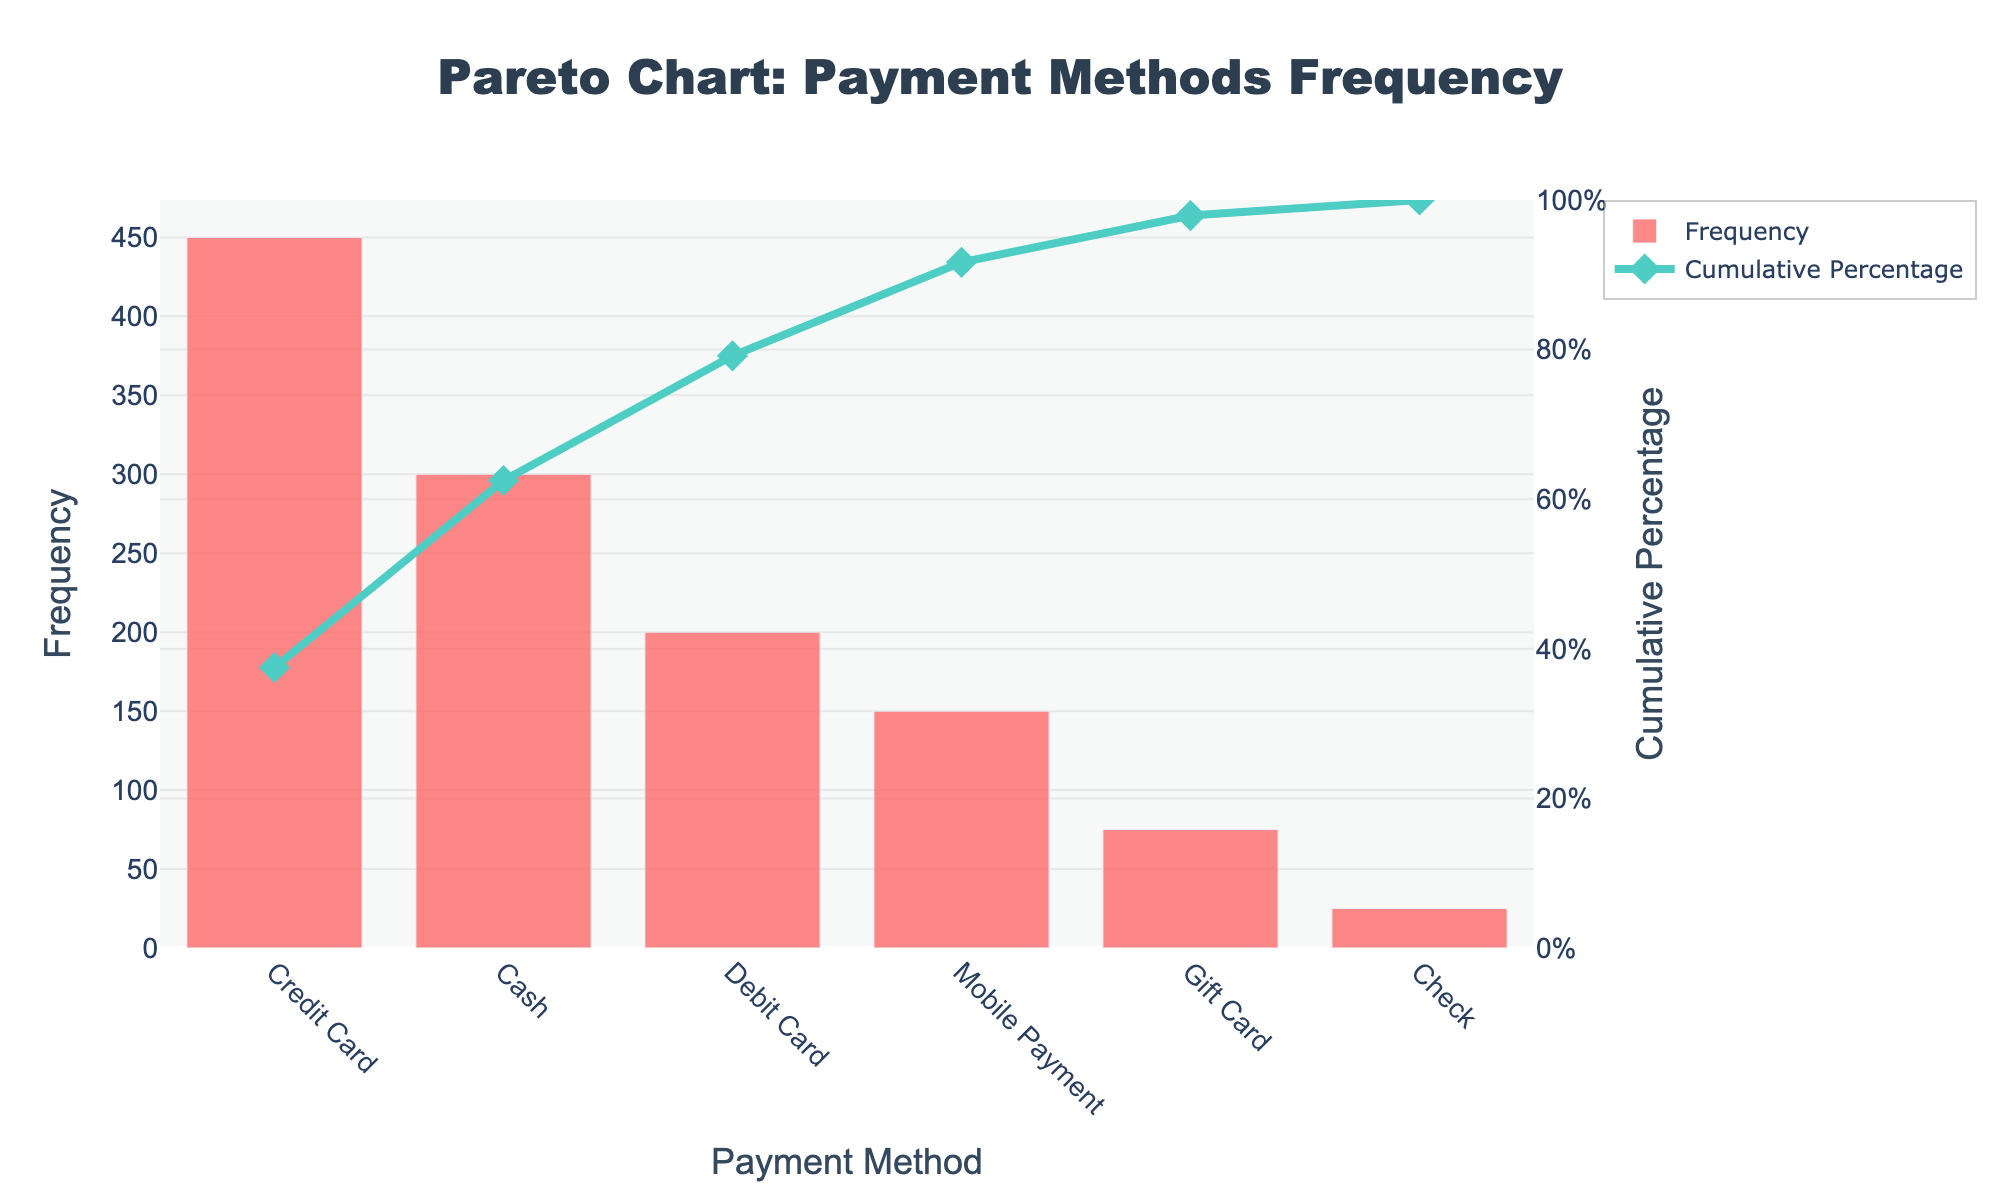What's the title of the Pareto chart? The title of the chart is located at the top and reads: "Pareto Chart: Payment Methods Frequency"
Answer: Pareto Chart: Payment Methods Frequency Which payment method has the highest frequency? From the bar chart, the payment method with the highest bar is "Credit Card" with a frequency of 450.
Answer: Credit Card What is the cumulative percentage for Debit Card? The cumulative percentage for "Debit Card" is shown on the line chart. It is approximately 81%.
Answer: 81% What two payment methods make up 75% of the cumulative percentage? To determine this, observe the cumulative percentage line chart. "Credit Card" (450) and "Cash" (300) together have a cumulative percentage of around 75%.
Answer: Credit Card and Cash How many payment methods are displayed on the x-axis? By counting the categories on the x-axis, we see there are 6 payment methods displayed: Credit Card, Cash, Debit Card, Mobile Payment, Gift Card, and Check.
Answer: 6 How does the frequency of Cash compare with Debit Card? From the bar chart, Cash has a higher frequency (300) compared to Debit Card (200).
Answer: Cash has a higher frequency than Debit Card What's the total cumulative percentage after including Mobile Payment? “Credit Card” (450), “Cash” (300), and “Debit Card” (200) contribute around 81%. Adding “Mobile Payment” (150) brings the total cumulative percentage close to 100%.
Answer: Close to 100% What is the difference in frequency between Mobile Payment and Gift Card? Mobile Payment has a frequency of 150 and Gift Card has a frequency of 75. The difference is calculated as 150 - 75 = 75.
Answer: 75 Which payment method has the least frequency and what is that frequency? The shortest bar on the bar chart corresponds to "Check", which has the least frequency of 25.
Answer: Check, 25 If you sum the frequencies of Gift Card and Check, what is the total? The frequency of Gift Card (75) and Check (25) together sum up to 75 + 25 = 100.
Answer: 100 